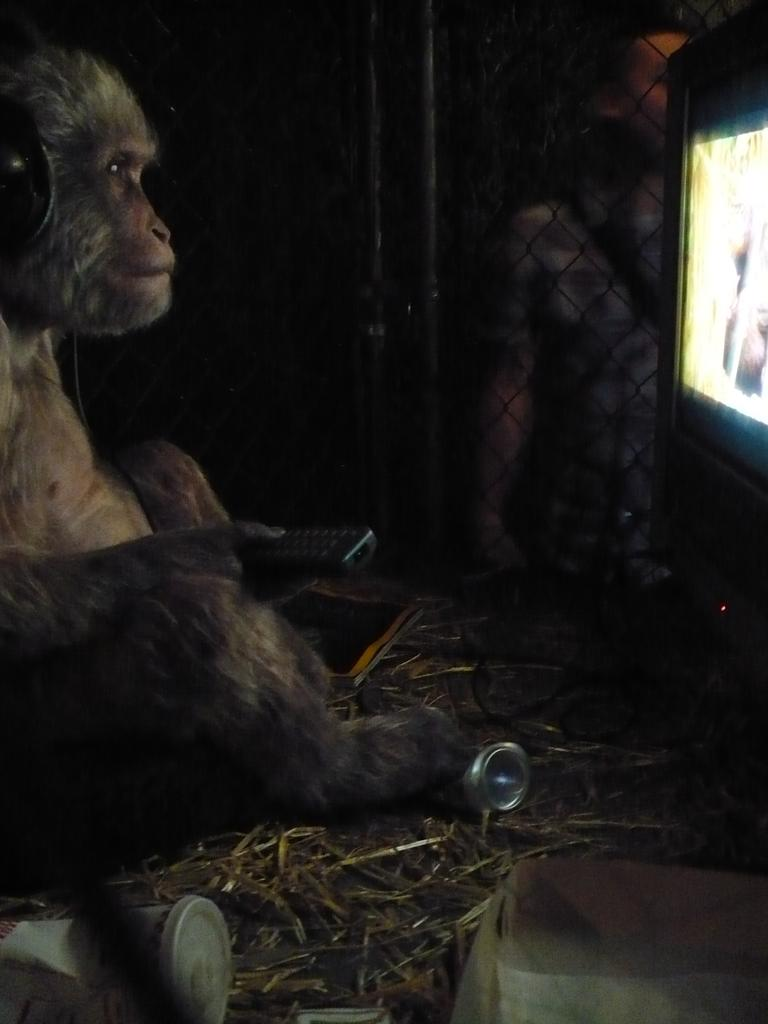What is the animal in the image holding? The animal is holding a remote in the image. What type of environment is depicted at the bottom of the image? There are tons and grass at the bottom of the image. What can be seen on the right side of the image? There is a screen on the right side of the image. What is present in the background of the image? There is a mesh in the background of the image. How does the animal express love to its partner in the image? There is no indication of a partner or any expression of love in the image; the animal is simply holding a remote. 